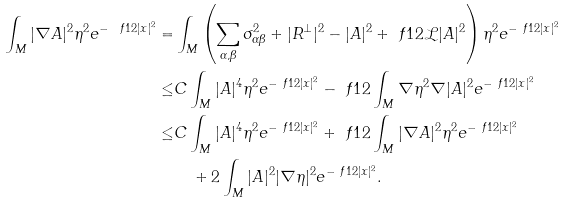Convert formula to latex. <formula><loc_0><loc_0><loc_500><loc_500>\int _ { M } | \nabla A | ^ { 2 } \eta ^ { 2 } e ^ { - \ f 1 2 | x | ^ { 2 } } = & \int _ { M } \left ( \sum _ { \alpha , \beta } \sigma _ { \alpha \beta } ^ { 2 } + | R ^ { \perp } | ^ { 2 } - | A | ^ { 2 } + \ f 1 2 \mathcal { L } | A | ^ { 2 } \right ) \eta ^ { 2 } e ^ { - \ f 1 2 | x | ^ { 2 } } \\ \leq & C \int _ { M } | A | ^ { 4 } \eta ^ { 2 } e ^ { - \ f 1 2 | x | ^ { 2 } } - \ f 1 2 \int _ { M } \nabla \eta ^ { 2 } \nabla | A | ^ { 2 } e ^ { - \ f 1 2 | x | ^ { 2 } } \\ \leq & C \int _ { M } | A | ^ { 4 } \eta ^ { 2 } e ^ { - \ f 1 2 | x | ^ { 2 } } + \ f 1 2 \int _ { M } | \nabla A | ^ { 2 } \eta ^ { 2 } e ^ { - \ f 1 2 | x | ^ { 2 } } \\ & \quad + 2 \int _ { M } | A | ^ { 2 } | \nabla \eta | ^ { 2 } e ^ { - \ f 1 2 | x | ^ { 2 } } .</formula> 